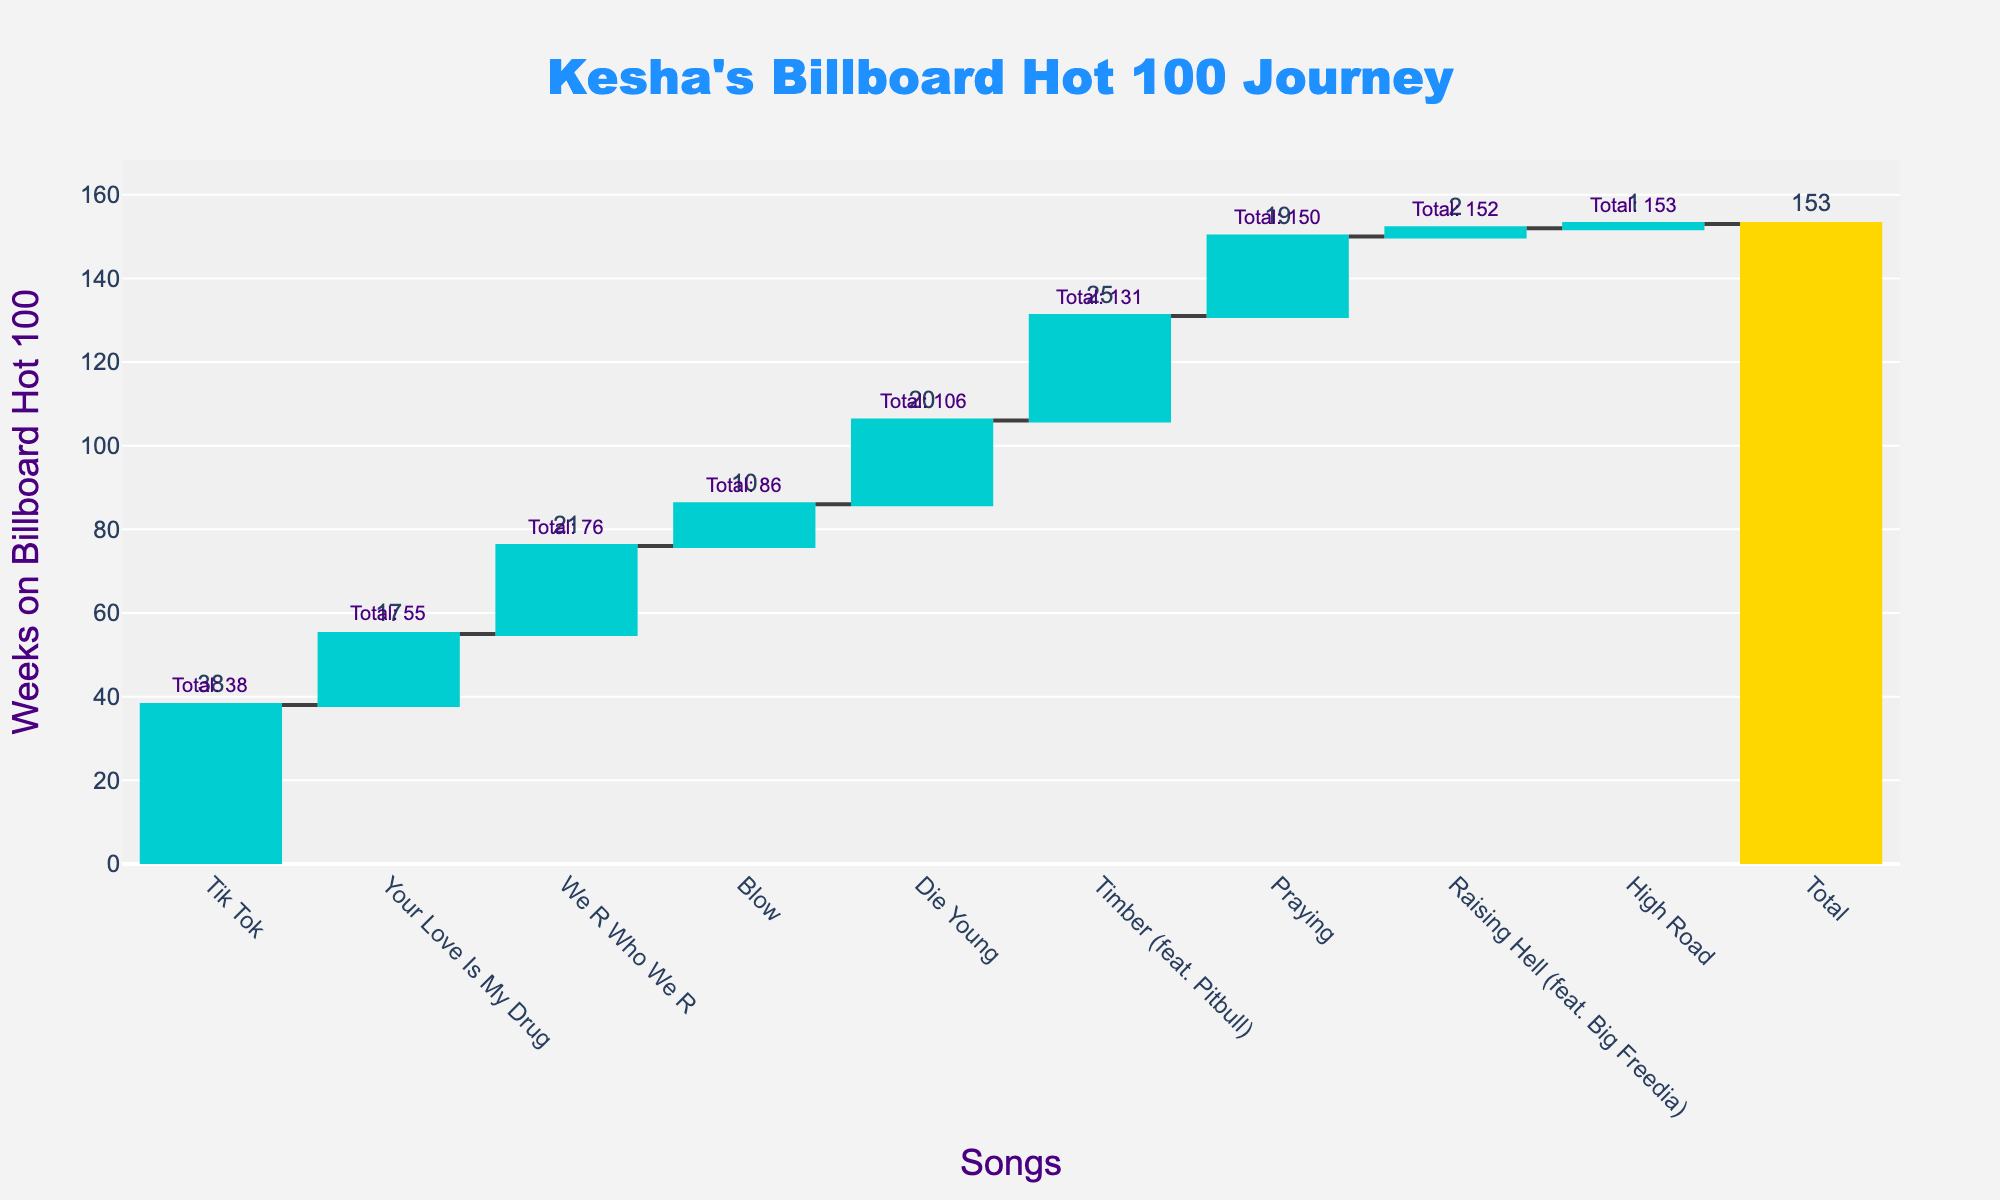How many songs of Kesha are represented in the chart? The chart lists the songs on the x-axis and counts the total number of distinct bars representing each song.
Answer: 8 What is the title of the chart? The title is displayed prominently at the top of the figure.
Answer: Kesha's Billboard Hot 100 Journey Which song had the highest number of weeks on the Billboard Hot 100? Compare the heights of the bars representing the 'Weeks on Hot 100' for each song.
Answer: Tik Tok What is the cumulative number of weeks on the Billboard Hot 100 for "Die Young"? Look at the cumulative value placed above the bar for "Die Young" on the chart.
Answer: 106 How many total cumulative weeks has Kesha spent on the Billboard Hot 100? The cumulative total is specified as the final value in the waterfall chart.
Answer: 153 Which song contributed the least to the total weeks on the Billboard Hot 100? Compare the heights of the bars to identify the smallest 'Weeks on Hot 100' value.
Answer: High Road How many weeks in total did "Timber (feat. Pitbull)" and "Praying" contribute? Sum the 'Weeks on Hot 100' for both "Timber (feat. Pitbull)" and "Praying".
Answer: 44 By how many weeks did "Blow" increase Kesha's total weeks on the Billboard Hot 100? Refer to the label on the bar for "Blow" indicating its 'Weeks on Hot 100'.
Answer: 10 Which song had more weeks on the Billboard Hot 100, "Your Love Is My Drug" or "Blow"? Compare the heights of the bars representing "Your Love Is My Drug" and "Blow".
Answer: Your Love Is My Drug What is the total increase in weeks after "Tik Tok" and "We R Who We R"? Sum the 'Weeks on Hot 100' for "Tik Tok" and "We R Who We R".
Answer: 59 